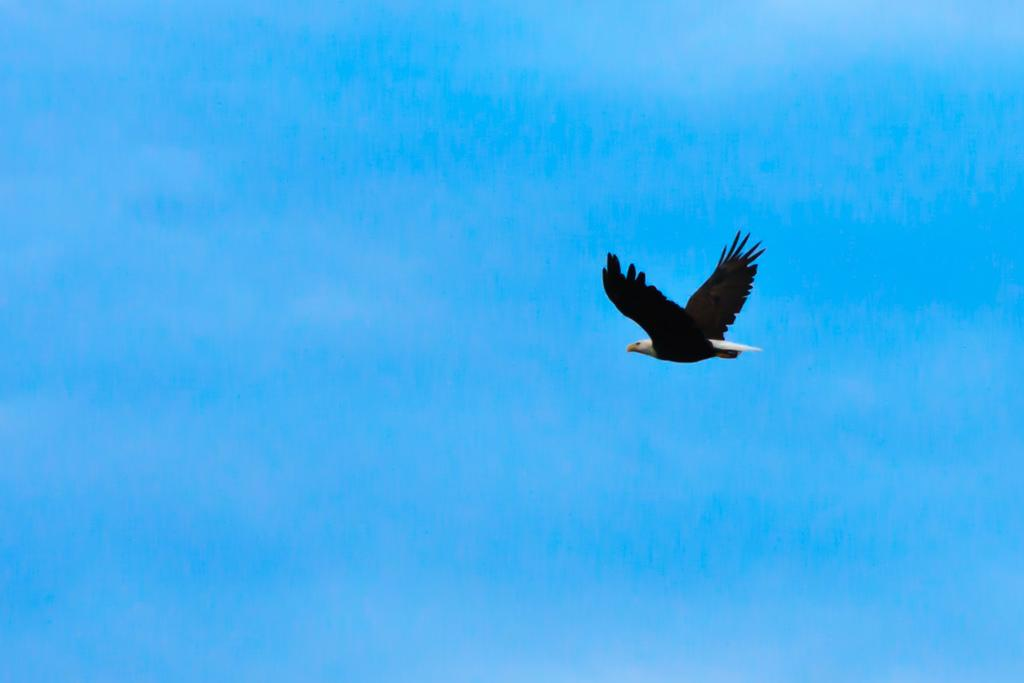What type of animal can be seen in the image? There is a bird in the image. What is the bird doing in the image? The bird is flying. What part of the natural environment is visible in the image? The sky is visible in the image. What type of stove can be seen in the image? There is no stove present in the image; it features a bird flying in the sky. How quiet is the market in the image? There is no market present in the image, so it cannot be determined how quiet it might be. 